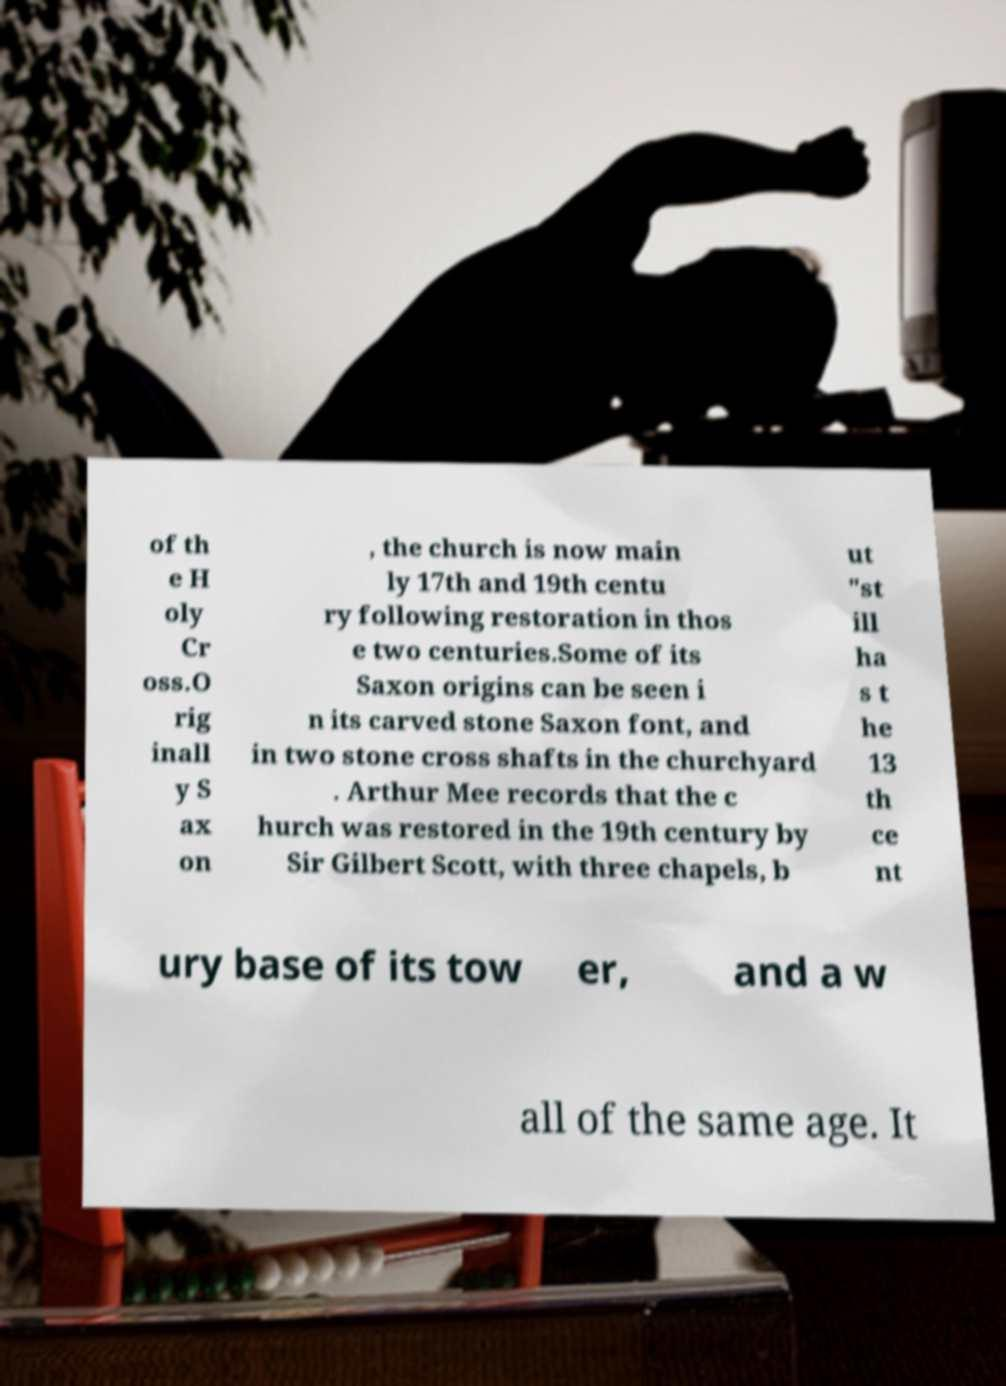Could you extract and type out the text from this image? of th e H oly Cr oss.O rig inall y S ax on , the church is now main ly 17th and 19th centu ry following restoration in thos e two centuries.Some of its Saxon origins can be seen i n its carved stone Saxon font, and in two stone cross shafts in the churchyard . Arthur Mee records that the c hurch was restored in the 19th century by Sir Gilbert Scott, with three chapels, b ut "st ill ha s t he 13 th ce nt ury base of its tow er, and a w all of the same age. It 